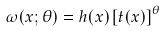Convert formula to latex. <formula><loc_0><loc_0><loc_500><loc_500>\omega ( x ; \theta ) = h ( x ) \left [ t ( x ) \right ] ^ { \theta }</formula> 